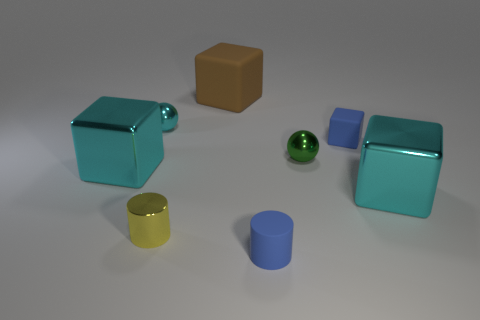Add 2 tiny blue rubber cubes. How many objects exist? 10 Subtract all cylinders. How many objects are left? 6 Subtract 1 green spheres. How many objects are left? 7 Subtract all small brown rubber objects. Subtract all blue matte cylinders. How many objects are left? 7 Add 7 blue rubber cylinders. How many blue rubber cylinders are left? 8 Add 7 big green things. How many big green things exist? 7 